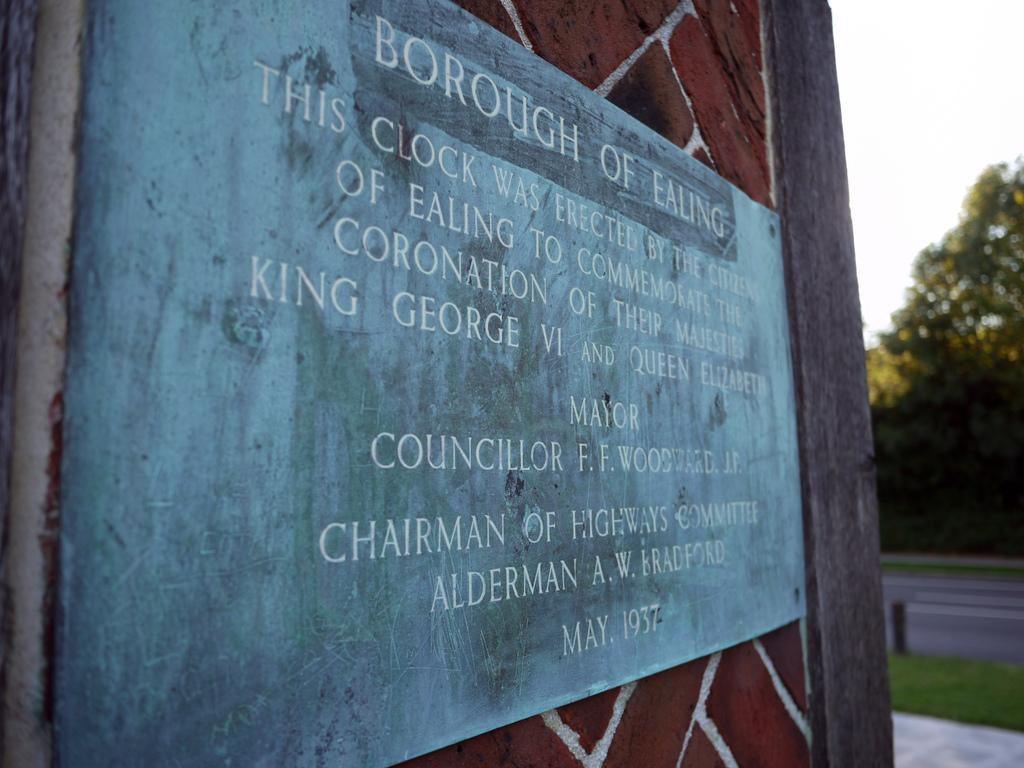<image>
Write a terse but informative summary of the picture. The sign for interested visitors tells of the reason for the erection of the clock at this location. 